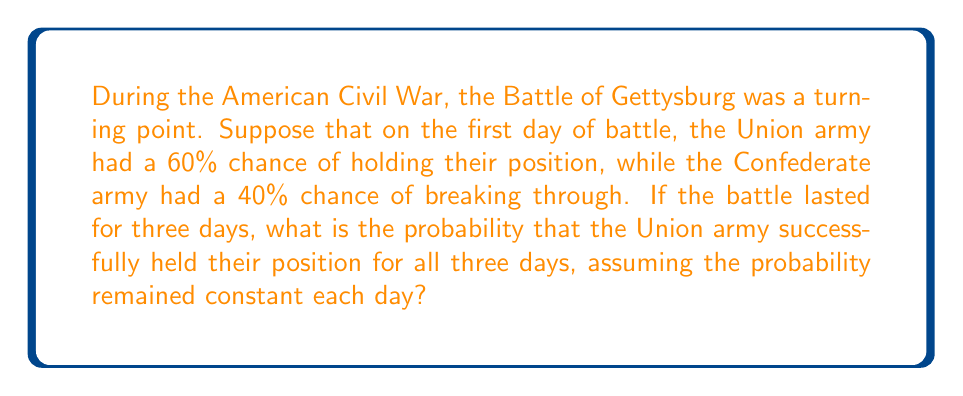Could you help me with this problem? To solve this problem, we need to use the concept of independent events in probability theory. Each day of the battle can be considered an independent event, as the outcome of one day doesn't affect the probability of the next day (given our assumption of constant probability).

The probability of an event occurring on all occasions is calculated by multiplying the individual probabilities of each occurrence.

Let's define our events:
$A$ = Union army holds their position for one day

We know that $P(A) = 0.60$ or 60%

We want to find the probability of this event occurring on all three days, which we can express as:

$P(A \text{ on day 1 AND } A \text{ on day 2 AND } A \text{ on day 3})$

Since these are independent events, we multiply the probabilities:

$$P(A \text{ for all 3 days}) = P(A) \times P(A) \times P(A)$$

$$P(A \text{ for all 3 days}) = 0.60 \times 0.60 \times 0.60$$

$$P(A \text{ for all 3 days}) = 0.60^3 = 0.216$$

Therefore, the probability that the Union army successfully held their position for all three days is 0.216 or 21.6%.

This result shows how the cumulative probability of success decreases over multiple independent trials, even when the probability of success for each individual trial is relatively high. In a historical context, this demonstrates the challenges faced by defending forces in prolonged battles, where they must consistently repel attacks over an extended period.
Answer: 0.216 or 21.6% 